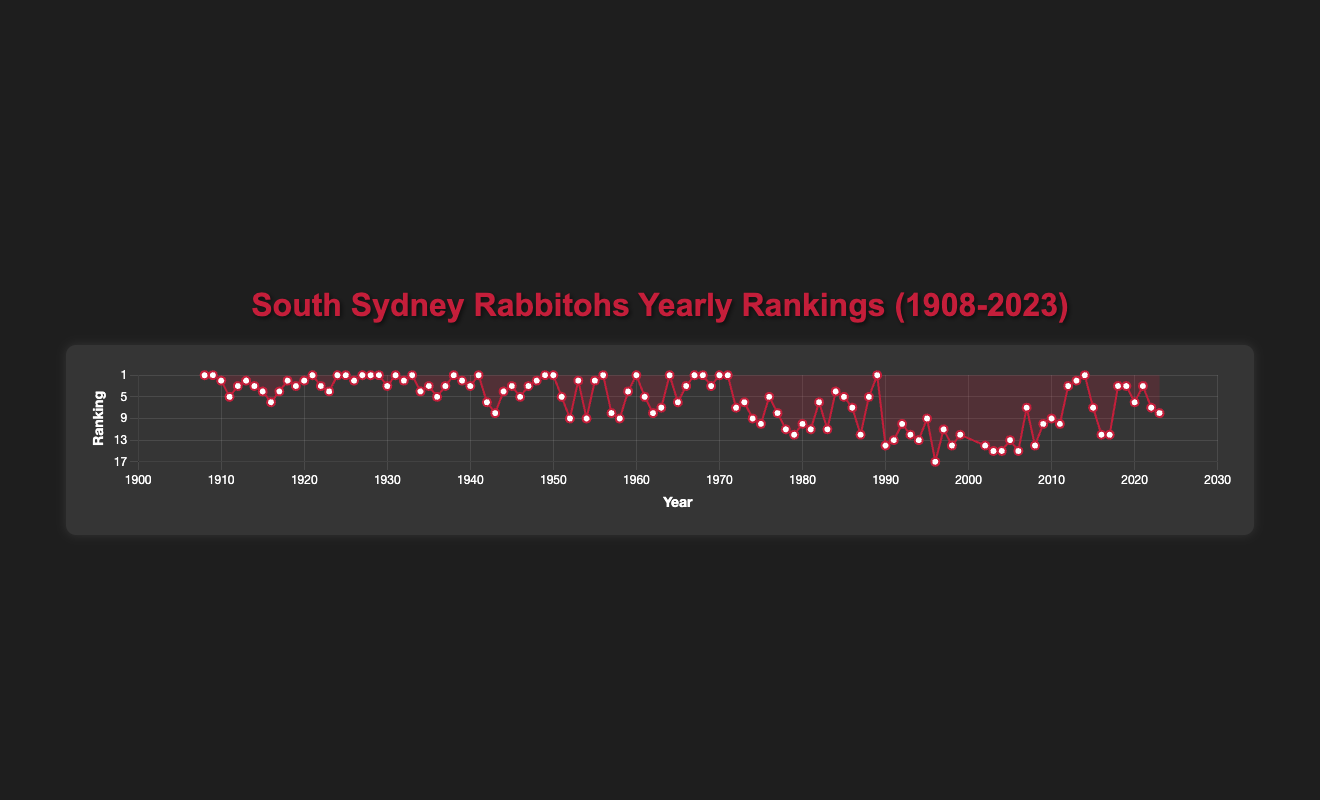Which year did the Rabbitohs achieve their lowest ranking? The lowest ranking on the chart is 17, which occurred in 1996. To verify, simply locate the point at ranking 17 and check the corresponding year.
Answer: 1996 How many times did the Rabbitohs finish in the top 3 from 1908 to 1950? Counting the occurrences where the ranking is 1, 2, or 3 between 1908 and 1950: 
1 (1908, 1909, 1921, 1924, 1925, 1927, 1928, 1929, 1931, 1933, 1938, 1941, 1949, 1950),
2 (1910, 1913, 1918, 1920, 1926, 1932, 1939, 1948, 1953, 1955),
3 (1912, 1914, 1919, 1930, 1935, 1937, 1940, 1944, 1945, 1947). The total is 34 times.
Answer: 34 What is the longest stretch of years where the Rabbitohs did not finish in the top 3? Based on the visual data, the longest stretch without a top 3 finish is from 1973 to 1998 (26 years). You can verify this by checking the absence of a ranking of 1, 2, or 3 during this period.
Answer: 26 years Which years did the Rabbitohs finish in the 7th position? Locate all the points at ranking 7 on the y-axis and check the corresponding years. The years are 1963, 1972, 2007, and 2022.
Answer: 1963, 1972, 2007, 2022 How did the ranking trend change between 2003 and 2007? Starting from 2003 with a rank of 15, the Rabbitohs' rank improved to 15 (2004), fell to 13 (2005), again to 15 (2006), and then significantly improved to 7 (2007). The trend shows overall improvement starting from 2005 to 2007.
Answer: Improved overall What is the average ranking of the Rabbitohs in the 2010s? The rankings from 2010 to 2019 are 9, 10, 3, 2, 1, 7, 12, 12, 3, and 3. Sum these values: 9 + 10 + 3 + 2 + 1 + 7 + 12 + 12 + 3 + 3 = 62. The average is 62 / 10 = 6.2.
Answer: 6.2 Compare the Rabbitohs' rankings in the 1920s and the 1980s. In which decade did they perform better? The average ranking in each decade is obtained by summing the rankings and dividing by the number of years:
1920s: 1, 3, 4, 1, 1, 2, 1, 1, 1, 3 = 18 / 10 = 1.8
1980s: 10, 11, 6, 11, 4, 5, 7, 12, 5, 1 = 72 / 10 = 7.2
The Rabbitohs performed better in the 1920s.
Answer: 1920s What was the Rabbitohs' ranking trend in the 1950s? The rankings in the 1950s were 1, 5, 9, 2, 9, 2, 1, 8, 9, 4. Initially, they started strong with a first-place finish, then experienced fluctuating ranks, ending the decade with a 4th place. The trend shows variability with some high placements and some mid-to-low ranks.
Answer: Fluctuating Which year did the Rabbitohs have the same rank as in their founding year, 1908? The Rabbitohs ranked first in 1908. To find another year with the same rank, look for a point with a rank of 1. Multiple such years exist: 1909, 1921, 1924, 1925, 1927, 1928, 1929, 1931, 1933, 1938, 1941, 1949, 1950, 1956, 1960, 1964, 1967, 1968, 1970, 1971, 1989, and 2014.
Answer: (Example) 1921 